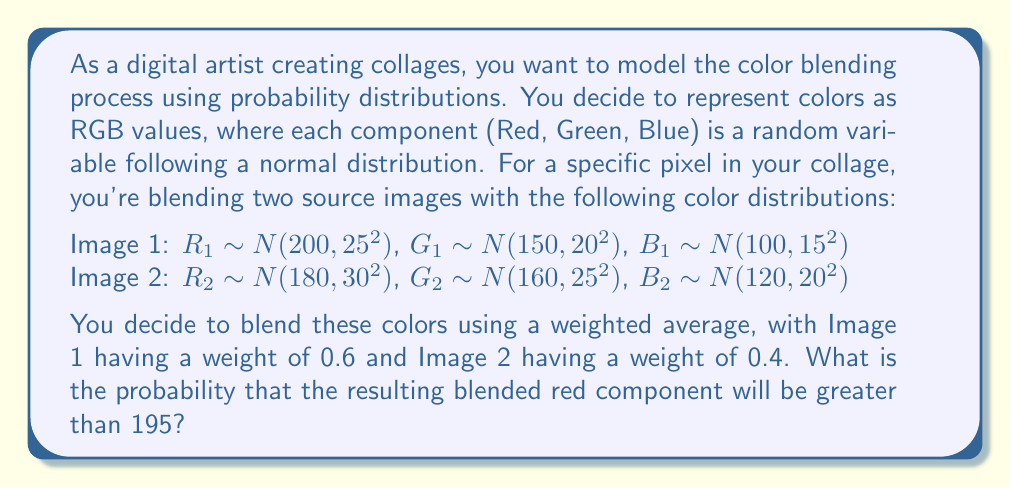Can you solve this math problem? To solve this problem, we need to follow these steps:

1. Determine the distribution of the blended red component.
2. Calculate the mean and standard deviation of this blended distribution.
3. Standardize the given value (195) and find the probability using the standard normal distribution.

Step 1: Blended red component distribution
The blended red component $R_b$ is a weighted sum of two normally distributed random variables:

$R_b = 0.6R_1 + 0.4R_2$

Since $R_1$ and $R_2$ are independent normal distributions, $R_b$ will also follow a normal distribution.

Step 2: Calculate mean and standard deviation
The mean of $R_b$ is:

$\mu_{R_b} = 0.6\mu_{R_1} + 0.4\mu_{R_2} = 0.6(200) + 0.4(180) = 192$

The variance of $R_b$ is:

$\sigma_{R_b}^2 = (0.6^2)(25^2) + (0.4^2)(30^2) = 225 + 144 = 369$

The standard deviation is:

$\sigma_{R_b} = \sqrt{369} \approx 19.21$

Step 3: Standardize and find probability
We want to find $P(R_b > 195)$. First, we standardize:

$z = \frac{195 - \mu_{R_b}}{\sigma_{R_b}} = \frac{195 - 192}{19.21} \approx 0.1562$

Now, we need to find $P(Z > 0.1562)$, where $Z$ is a standard normal random variable. This is equal to $1 - P(Z < 0.1562)$.

Using a standard normal table or calculator, we find:

$P(Z < 0.1562) \approx 0.5621$

Therefore, $P(R_b > 195) = 1 - 0.5621 = 0.4379$
Answer: The probability that the resulting blended red component will be greater than 195 is approximately 0.4379 or 43.79%. 